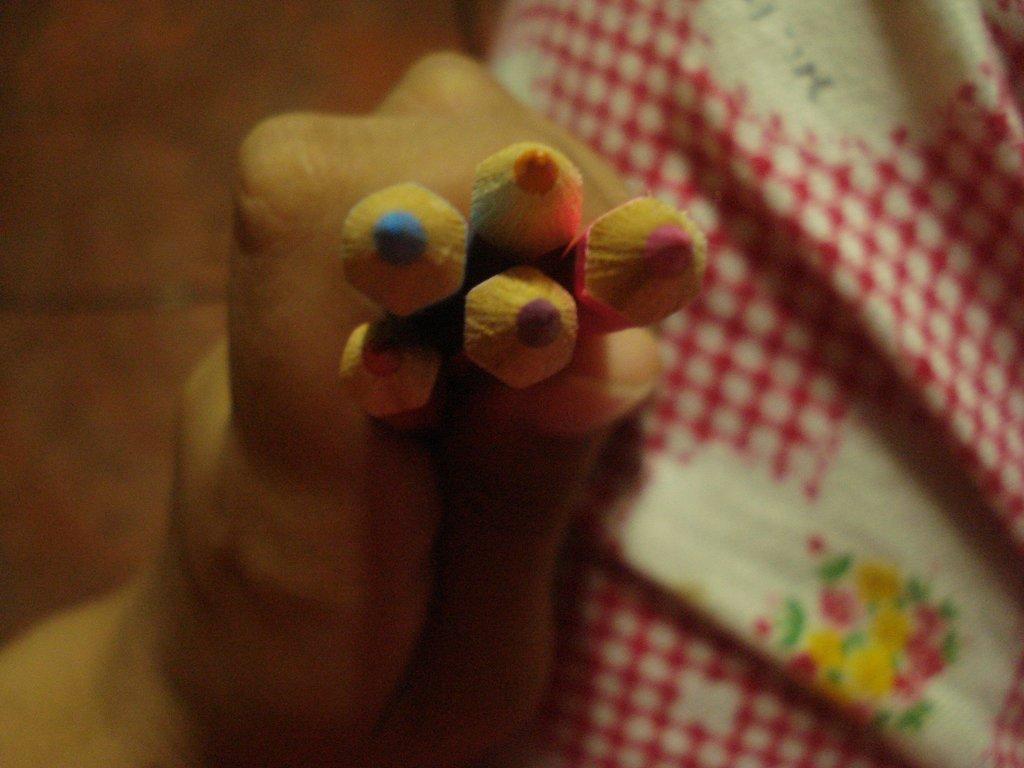How would you summarize this image in a sentence or two? In the picture there is a person catching some pencils with the hand, beside there is a cloth, on the cloth there is some design present. 